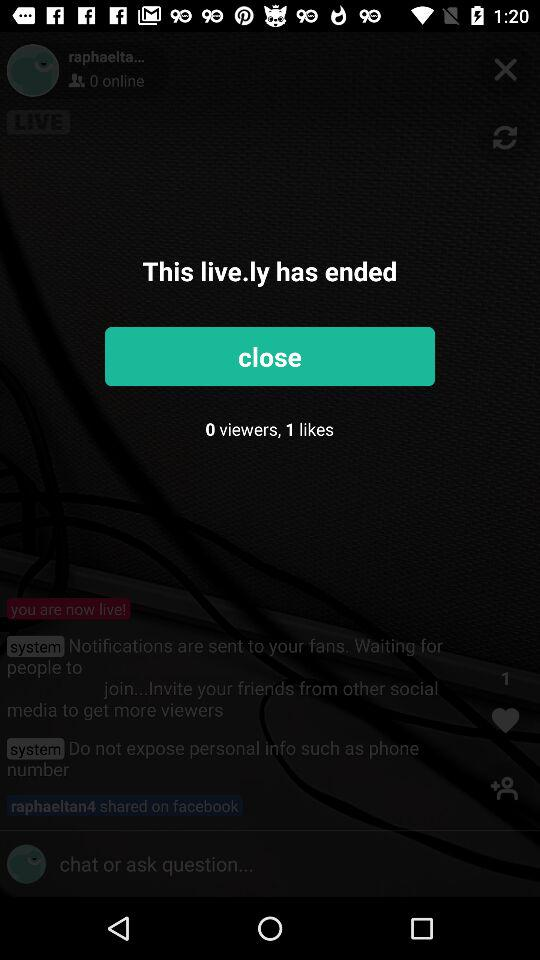How many viewers are shown on the screen? There are 0 viewers. 